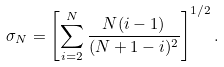Convert formula to latex. <formula><loc_0><loc_0><loc_500><loc_500>\sigma _ { N } = \left [ \sum _ { i = 2 } ^ { N } \frac { N ( i - 1 ) } { ( N + 1 - i ) ^ { 2 } } \right ] ^ { 1 / 2 } .</formula> 